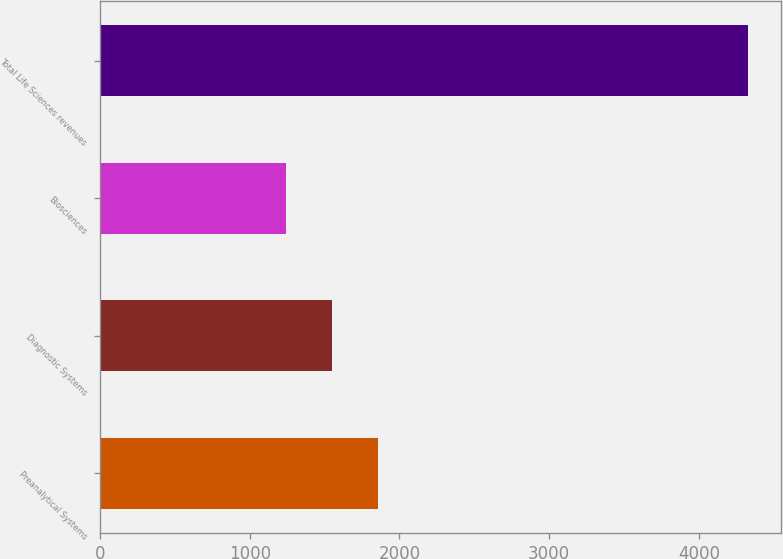Convert chart to OTSL. <chart><loc_0><loc_0><loc_500><loc_500><bar_chart><fcel>Preanalytical Systems<fcel>Diagnostic Systems<fcel>Biosciences<fcel>Total Life Sciences revenues<nl><fcel>1858.8<fcel>1549.9<fcel>1241<fcel>4330<nl></chart> 